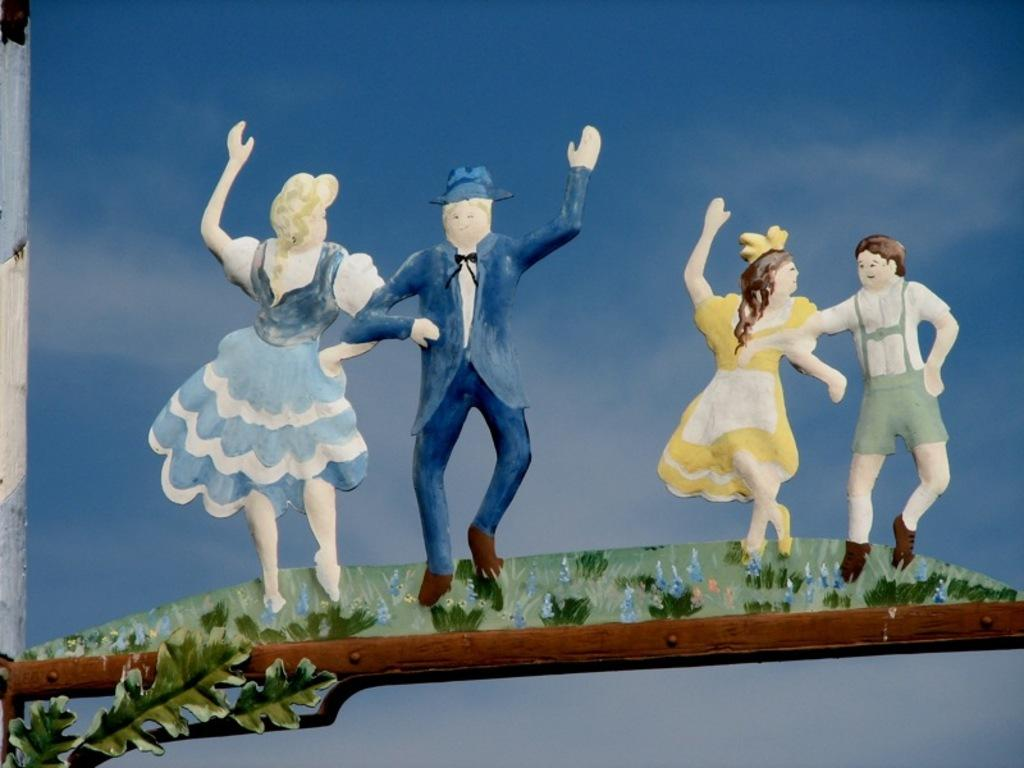What is the main subject of the image? There is a painting in the image. What is depicted in the painting? The painting depicts two couples. Where are the couples standing in the painting? The couples are standing on a grass surface. What is in front of the couples in the painting? There is a leaf and a wooden platform in front of the couples. What level of difficulty does the painting present for a beginner artist? The image does not provide information about the level of difficulty for a beginner artist, as it only shows the painting and its content. What type of disease is depicted in the painting? There is no disease depicted in the painting; it features two couples standing on a grass surface with a leaf and a wooden platform in front of them. 